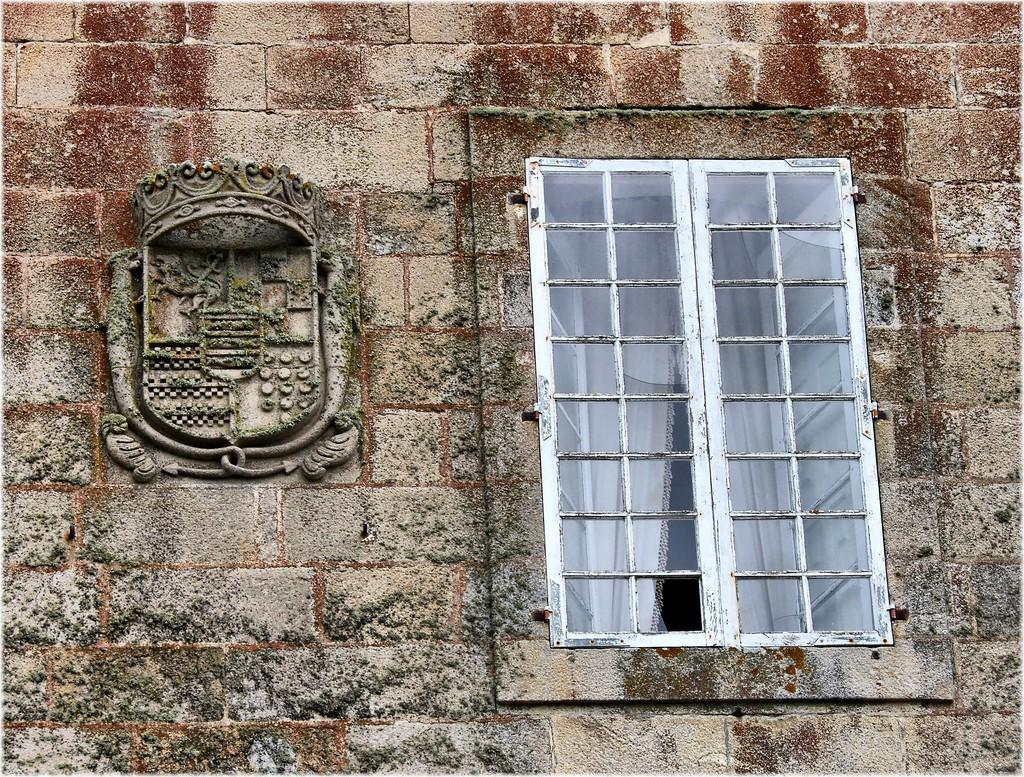What can be seen in the image that allows light to enter the room? There is a window in the image. What type of window treatment is present in the image? There are curtains associated with the window. What type of artwork is present on the wall in the image? There is a sculpture on the wall in the image. What type of stone is the brother using to show his collection in the image? There is no stone, brother, or collection present in the image. 